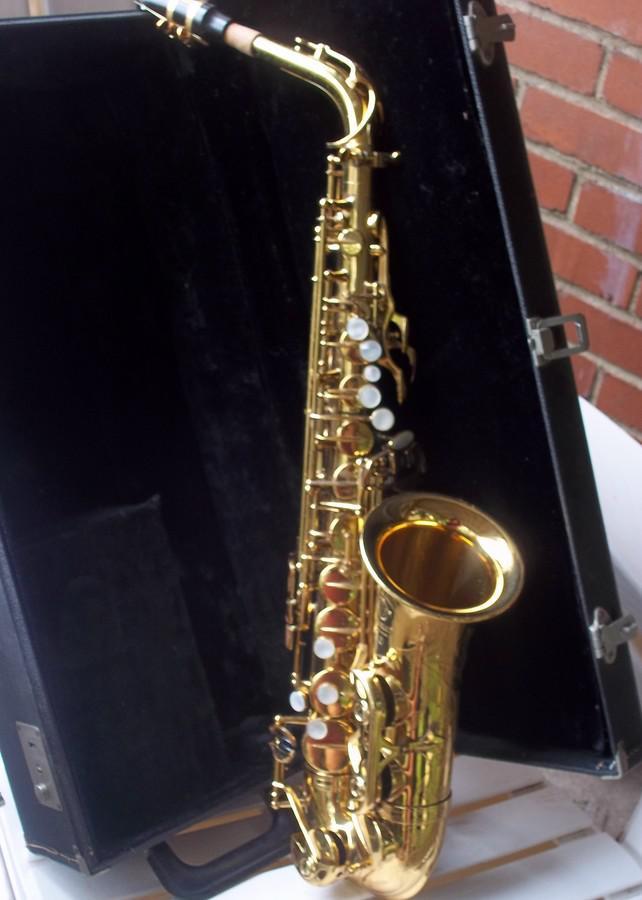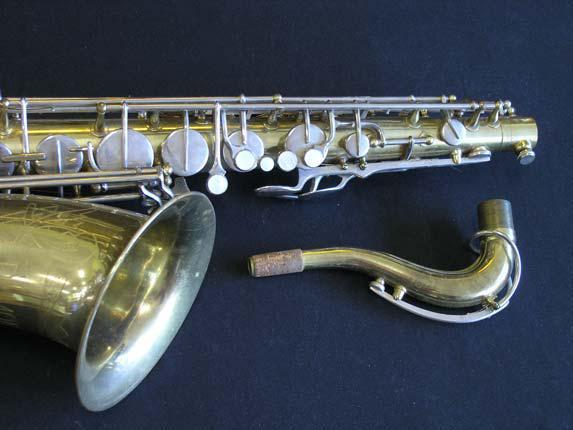The first image is the image on the left, the second image is the image on the right. Assess this claim about the two images: "The sax in the image on the left has etching on it.". Correct or not? Answer yes or no. No. The first image is the image on the left, the second image is the image on the right. Assess this claim about the two images: "The left image shows a saxophone displayed in front of an open black case, and the right image features a saxophone displayed without a case.". Correct or not? Answer yes or no. Yes. 